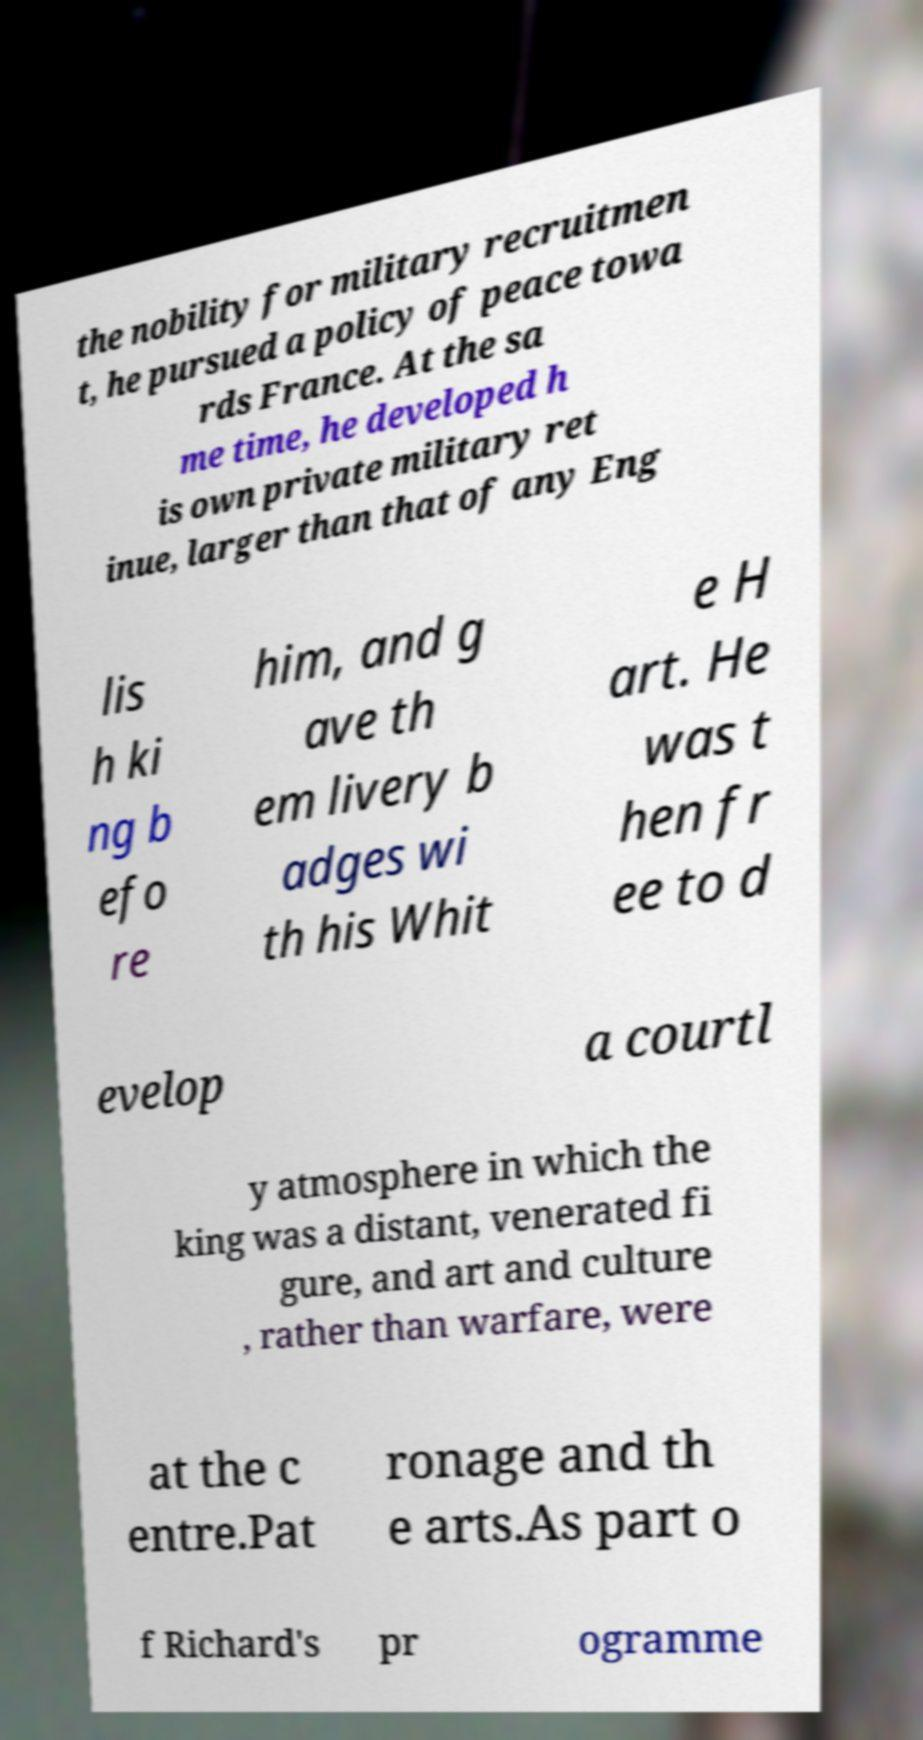What messages or text are displayed in this image? I need them in a readable, typed format. the nobility for military recruitmen t, he pursued a policy of peace towa rds France. At the sa me time, he developed h is own private military ret inue, larger than that of any Eng lis h ki ng b efo re him, and g ave th em livery b adges wi th his Whit e H art. He was t hen fr ee to d evelop a courtl y atmosphere in which the king was a distant, venerated fi gure, and art and culture , rather than warfare, were at the c entre.Pat ronage and th e arts.As part o f Richard's pr ogramme 